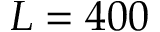Convert formula to latex. <formula><loc_0><loc_0><loc_500><loc_500>L = 4 0 0</formula> 